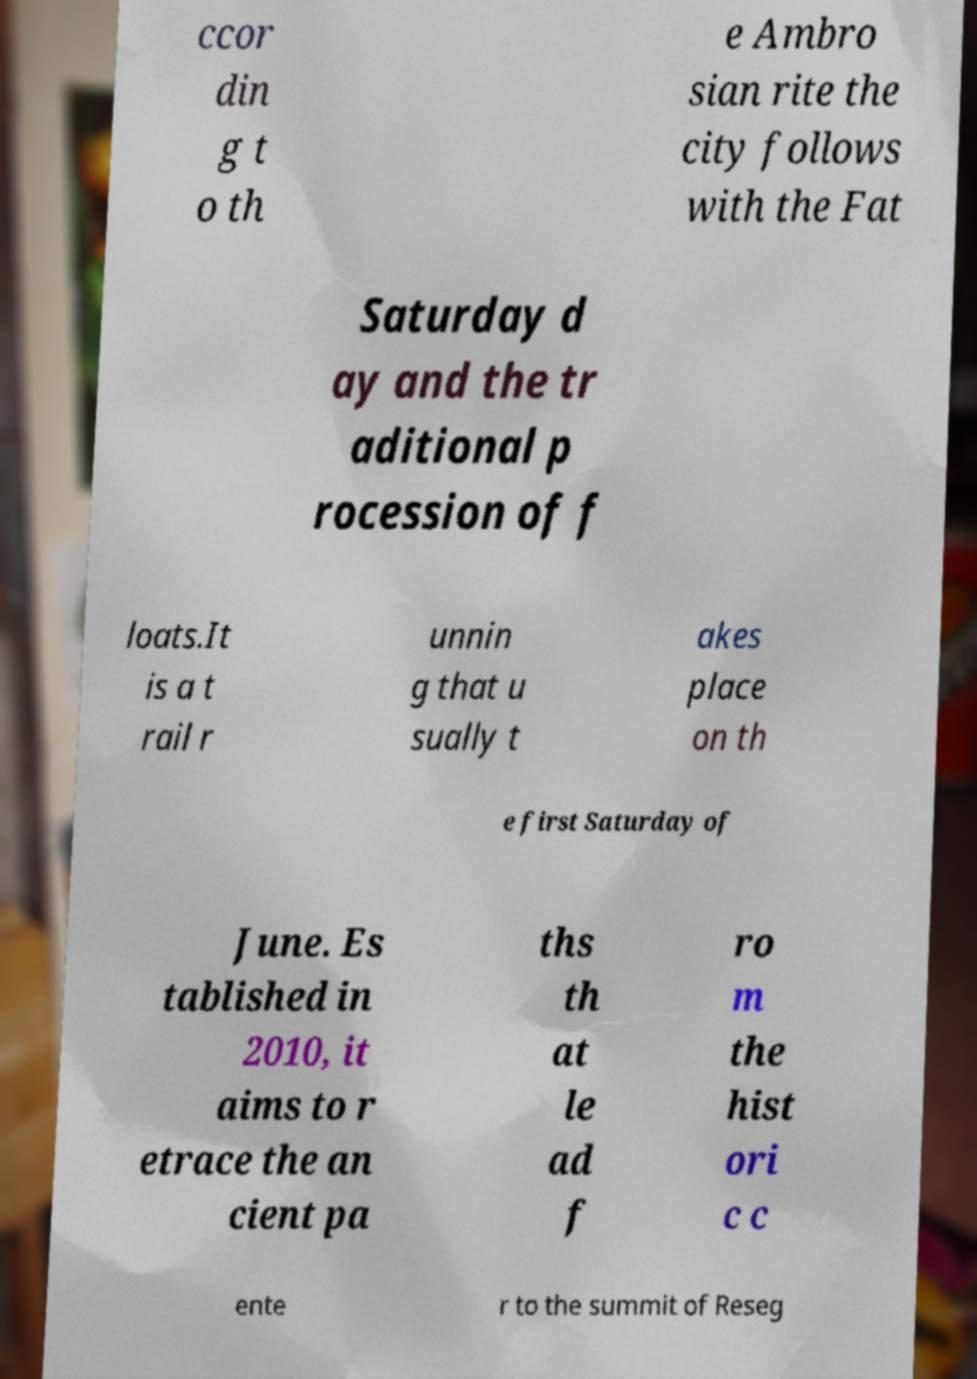What messages or text are displayed in this image? I need them in a readable, typed format. ccor din g t o th e Ambro sian rite the city follows with the Fat Saturday d ay and the tr aditional p rocession of f loats.It is a t rail r unnin g that u sually t akes place on th e first Saturday of June. Es tablished in 2010, it aims to r etrace the an cient pa ths th at le ad f ro m the hist ori c c ente r to the summit of Reseg 